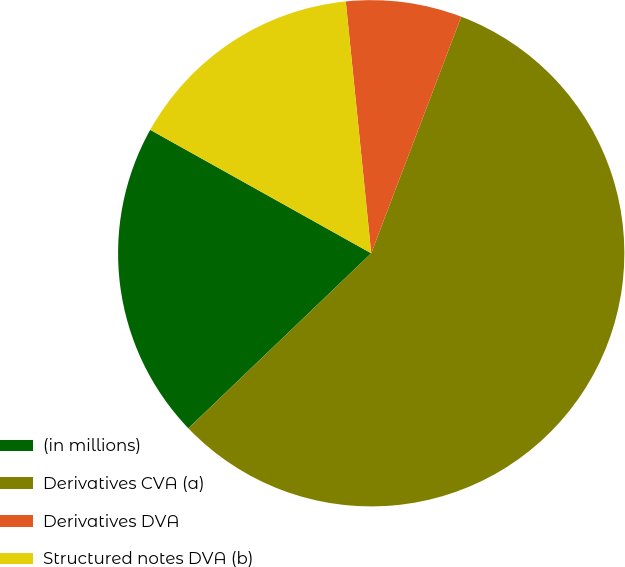Convert chart to OTSL. <chart><loc_0><loc_0><loc_500><loc_500><pie_chart><fcel>(in millions)<fcel>Derivatives CVA (a)<fcel>Derivatives DVA<fcel>Structured notes DVA (b)<nl><fcel>20.26%<fcel>57.06%<fcel>7.39%<fcel>15.29%<nl></chart> 